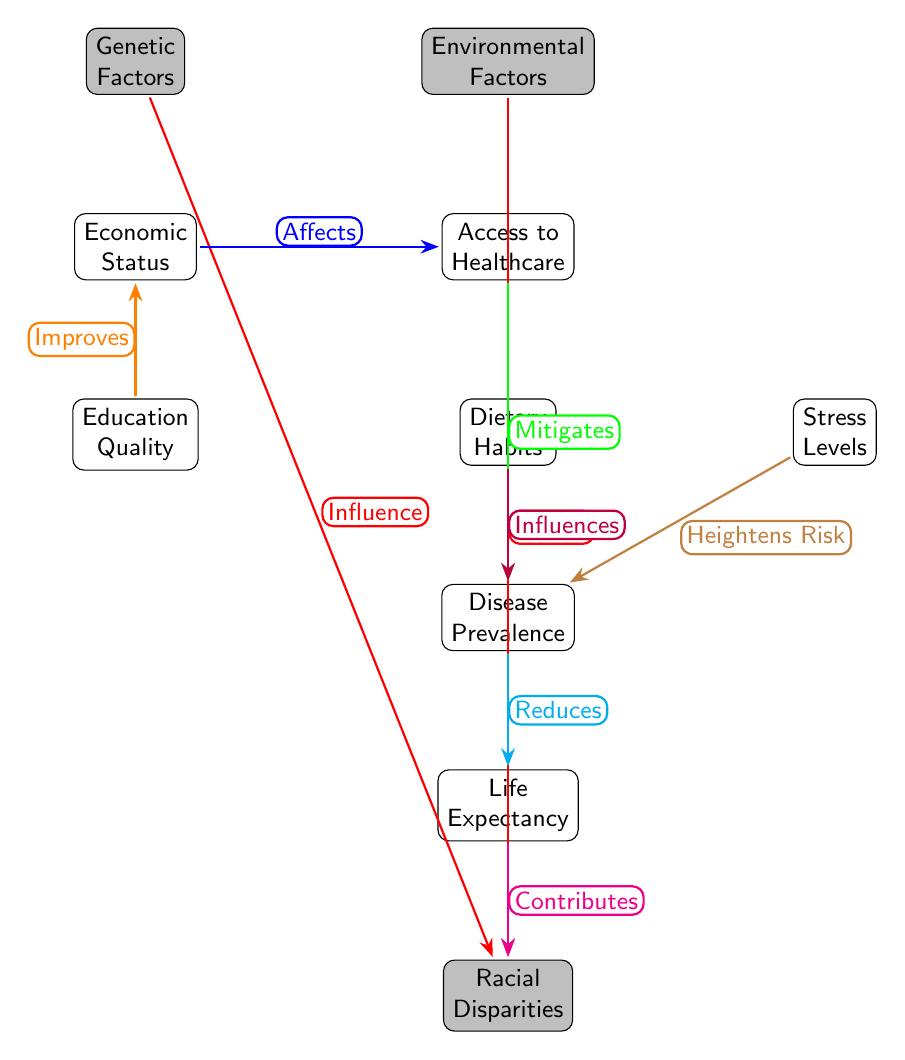What are the two primary factors illustrated in the top section of the diagram? The diagram prominently depicts "Genetic Factors" on the left and "Environmental Factors" on the right as the main components influencing racial disparities.
Answer: Genetic Factors, Environmental Factors How many nodes are represented in the diagram? The diagram consists of a total of 9 nodes, which include genetic, environmental, economic status, healthcare, education, dietary habits, stress levels, disease prevalence, life expectancy, and racial disparities.
Answer: 9 What does "Economic Status" affect according to the arrows in the diagram? "Economic Status" leads directly to "Access to Healthcare", showing that it impacts healthcare accessibility in this context.
Answer: Access to Healthcare Which factor is indicated as influencing "Disease Prevalence" on the diagram? Both "Dietary Habits" and "Stress Levels" have arrows pointing toward "Disease Prevalence", indicating their influence on disease rates.
Answer: Dietary Habits, Stress Levels What is the final factor presented in the diagram that contributes to "Racial Disparities"? The pathway shows that "Life Expectancy" plays a crucial role as a contributing factor to "Racial Disparities," linking these two concepts.
Answer: Life Expectancy How does "Healthcare" relate to "Disease Prevalence"? The arrow indicates that "Access to Healthcare" mitigates or reduces the impact of "Disease Prevalence", suggesting a protective factor in health outcomes.
Answer: Mitigates Explain the overall flow from "Genetic Factors" to "Racial Disparities". The flow begins with "Genetic Factors" which directly influences "Racial Disparities". Concurrently, "Environmental Factors" also impacts "Racial Disparities" and the flow connects multiple nodes like Healthcare, Economic Status, and Education, which interact to compound the effects on disparities.
Answer: Genetic Factors influence Racial Disparities Which node does "Education Quality" directly improve according to the diagram? The diagram illustrates that "Education Quality" has a direct positive effect on "Economic Status", showing a pathway for how education can elevate economic conditions.
Answer: Economic Status What type of relationship does "Stress Levels" have with "Disease Prevalence"? The relationship is depicted as a heightening risk, suggesting that increased stress contributes negatively to disease prevalence.
Answer: Heightens Risk 